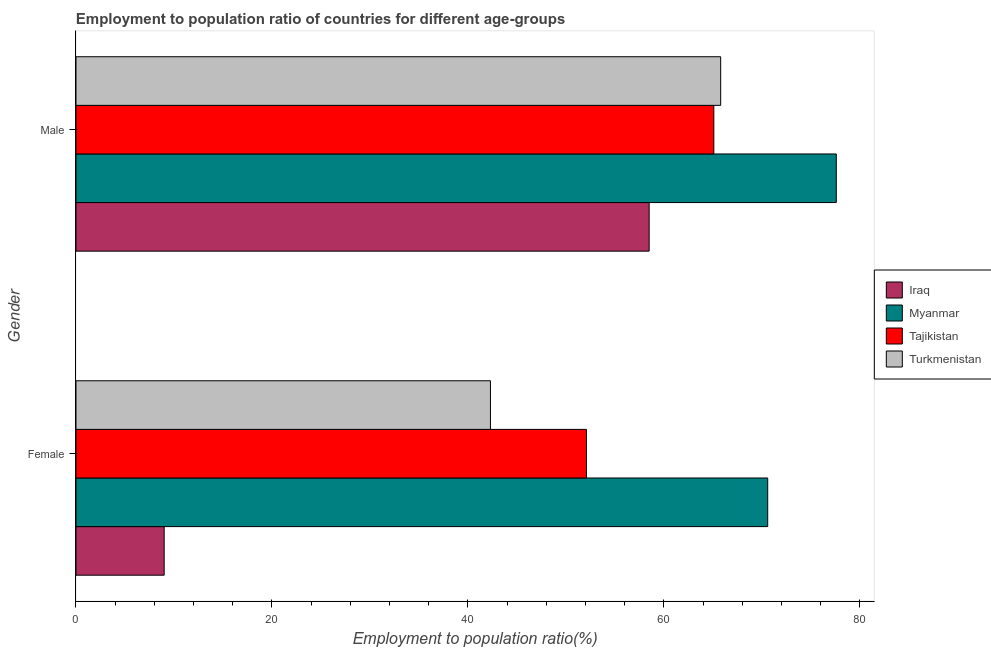How many different coloured bars are there?
Your answer should be very brief. 4. How many groups of bars are there?
Offer a very short reply. 2. Are the number of bars per tick equal to the number of legend labels?
Provide a short and direct response. Yes. Are the number of bars on each tick of the Y-axis equal?
Provide a succinct answer. Yes. How many bars are there on the 1st tick from the top?
Provide a short and direct response. 4. How many bars are there on the 2nd tick from the bottom?
Make the answer very short. 4. What is the label of the 1st group of bars from the top?
Your response must be concise. Male. What is the employment to population ratio(male) in Iraq?
Provide a short and direct response. 58.5. Across all countries, what is the maximum employment to population ratio(male)?
Provide a short and direct response. 77.6. Across all countries, what is the minimum employment to population ratio(male)?
Keep it short and to the point. 58.5. In which country was the employment to population ratio(male) maximum?
Offer a terse response. Myanmar. In which country was the employment to population ratio(male) minimum?
Offer a very short reply. Iraq. What is the total employment to population ratio(male) in the graph?
Your answer should be very brief. 267. What is the difference between the employment to population ratio(male) in Iraq and that in Turkmenistan?
Ensure brevity in your answer.  -7.3. What is the difference between the employment to population ratio(female) in Turkmenistan and the employment to population ratio(male) in Myanmar?
Provide a succinct answer. -35.3. What is the average employment to population ratio(male) per country?
Your response must be concise. 66.75. What is the difference between the employment to population ratio(male) and employment to population ratio(female) in Turkmenistan?
Offer a terse response. 23.5. What is the ratio of the employment to population ratio(male) in Myanmar to that in Tajikistan?
Your response must be concise. 1.19. In how many countries, is the employment to population ratio(female) greater than the average employment to population ratio(female) taken over all countries?
Give a very brief answer. 2. What does the 4th bar from the top in Female represents?
Offer a very short reply. Iraq. What does the 3rd bar from the bottom in Female represents?
Give a very brief answer. Tajikistan. Are the values on the major ticks of X-axis written in scientific E-notation?
Your answer should be very brief. No. Does the graph contain grids?
Your response must be concise. No. What is the title of the graph?
Your response must be concise. Employment to population ratio of countries for different age-groups. What is the label or title of the X-axis?
Offer a terse response. Employment to population ratio(%). What is the Employment to population ratio(%) of Myanmar in Female?
Your response must be concise. 70.6. What is the Employment to population ratio(%) in Tajikistan in Female?
Provide a succinct answer. 52.1. What is the Employment to population ratio(%) of Turkmenistan in Female?
Offer a very short reply. 42.3. What is the Employment to population ratio(%) in Iraq in Male?
Your response must be concise. 58.5. What is the Employment to population ratio(%) of Myanmar in Male?
Your answer should be very brief. 77.6. What is the Employment to population ratio(%) of Tajikistan in Male?
Make the answer very short. 65.1. What is the Employment to population ratio(%) in Turkmenistan in Male?
Your answer should be compact. 65.8. Across all Gender, what is the maximum Employment to population ratio(%) of Iraq?
Your answer should be compact. 58.5. Across all Gender, what is the maximum Employment to population ratio(%) of Myanmar?
Your answer should be compact. 77.6. Across all Gender, what is the maximum Employment to population ratio(%) in Tajikistan?
Your answer should be very brief. 65.1. Across all Gender, what is the maximum Employment to population ratio(%) in Turkmenistan?
Your answer should be compact. 65.8. Across all Gender, what is the minimum Employment to population ratio(%) in Myanmar?
Offer a very short reply. 70.6. Across all Gender, what is the minimum Employment to population ratio(%) in Tajikistan?
Offer a terse response. 52.1. Across all Gender, what is the minimum Employment to population ratio(%) of Turkmenistan?
Your answer should be compact. 42.3. What is the total Employment to population ratio(%) in Iraq in the graph?
Offer a terse response. 67.5. What is the total Employment to population ratio(%) in Myanmar in the graph?
Your response must be concise. 148.2. What is the total Employment to population ratio(%) of Tajikistan in the graph?
Provide a short and direct response. 117.2. What is the total Employment to population ratio(%) of Turkmenistan in the graph?
Provide a succinct answer. 108.1. What is the difference between the Employment to population ratio(%) in Iraq in Female and that in Male?
Provide a short and direct response. -49.5. What is the difference between the Employment to population ratio(%) in Myanmar in Female and that in Male?
Your answer should be compact. -7. What is the difference between the Employment to population ratio(%) of Turkmenistan in Female and that in Male?
Offer a very short reply. -23.5. What is the difference between the Employment to population ratio(%) of Iraq in Female and the Employment to population ratio(%) of Myanmar in Male?
Provide a succinct answer. -68.6. What is the difference between the Employment to population ratio(%) in Iraq in Female and the Employment to population ratio(%) in Tajikistan in Male?
Your answer should be very brief. -56.1. What is the difference between the Employment to population ratio(%) in Iraq in Female and the Employment to population ratio(%) in Turkmenistan in Male?
Your response must be concise. -56.8. What is the difference between the Employment to population ratio(%) of Myanmar in Female and the Employment to population ratio(%) of Tajikistan in Male?
Give a very brief answer. 5.5. What is the difference between the Employment to population ratio(%) in Tajikistan in Female and the Employment to population ratio(%) in Turkmenistan in Male?
Offer a terse response. -13.7. What is the average Employment to population ratio(%) in Iraq per Gender?
Make the answer very short. 33.75. What is the average Employment to population ratio(%) of Myanmar per Gender?
Keep it short and to the point. 74.1. What is the average Employment to population ratio(%) of Tajikistan per Gender?
Your response must be concise. 58.6. What is the average Employment to population ratio(%) in Turkmenistan per Gender?
Offer a very short reply. 54.05. What is the difference between the Employment to population ratio(%) in Iraq and Employment to population ratio(%) in Myanmar in Female?
Provide a short and direct response. -61.6. What is the difference between the Employment to population ratio(%) of Iraq and Employment to population ratio(%) of Tajikistan in Female?
Your response must be concise. -43.1. What is the difference between the Employment to population ratio(%) in Iraq and Employment to population ratio(%) in Turkmenistan in Female?
Offer a terse response. -33.3. What is the difference between the Employment to population ratio(%) in Myanmar and Employment to population ratio(%) in Turkmenistan in Female?
Offer a terse response. 28.3. What is the difference between the Employment to population ratio(%) of Tajikistan and Employment to population ratio(%) of Turkmenistan in Female?
Give a very brief answer. 9.8. What is the difference between the Employment to population ratio(%) in Iraq and Employment to population ratio(%) in Myanmar in Male?
Keep it short and to the point. -19.1. What is the ratio of the Employment to population ratio(%) of Iraq in Female to that in Male?
Give a very brief answer. 0.15. What is the ratio of the Employment to population ratio(%) of Myanmar in Female to that in Male?
Provide a succinct answer. 0.91. What is the ratio of the Employment to population ratio(%) in Tajikistan in Female to that in Male?
Your answer should be very brief. 0.8. What is the ratio of the Employment to population ratio(%) in Turkmenistan in Female to that in Male?
Provide a succinct answer. 0.64. What is the difference between the highest and the second highest Employment to population ratio(%) in Iraq?
Offer a terse response. 49.5. What is the difference between the highest and the second highest Employment to population ratio(%) of Myanmar?
Your answer should be compact. 7. What is the difference between the highest and the lowest Employment to population ratio(%) of Iraq?
Your response must be concise. 49.5. What is the difference between the highest and the lowest Employment to population ratio(%) of Myanmar?
Your response must be concise. 7. What is the difference between the highest and the lowest Employment to population ratio(%) of Tajikistan?
Ensure brevity in your answer.  13. 